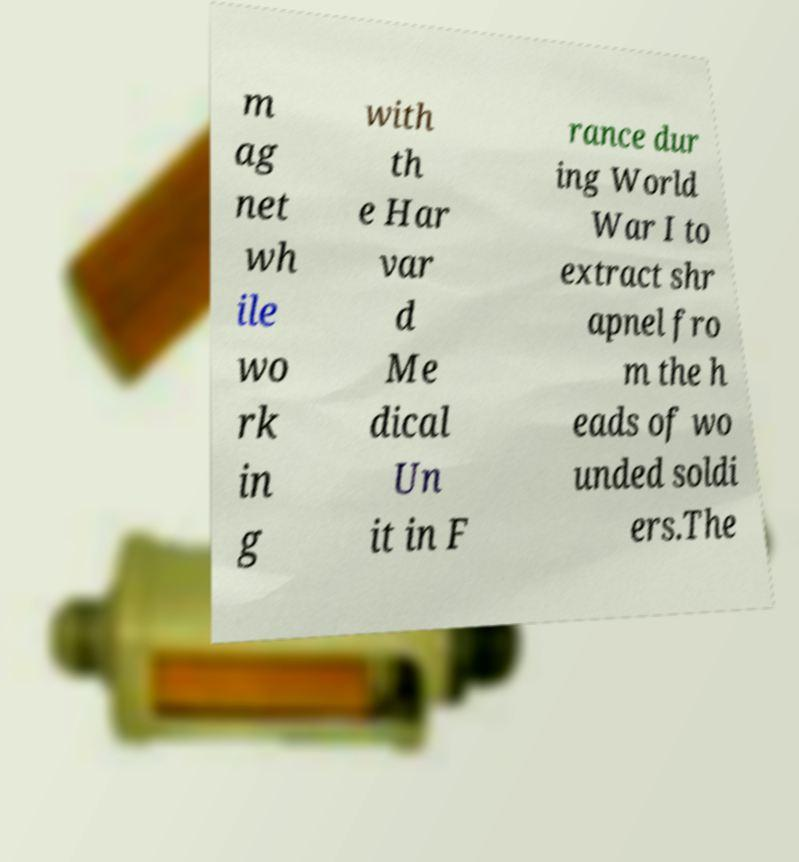Please identify and transcribe the text found in this image. m ag net wh ile wo rk in g with th e Har var d Me dical Un it in F rance dur ing World War I to extract shr apnel fro m the h eads of wo unded soldi ers.The 